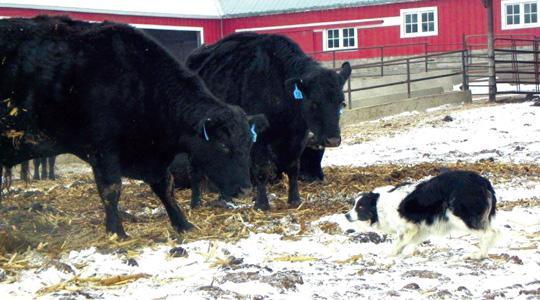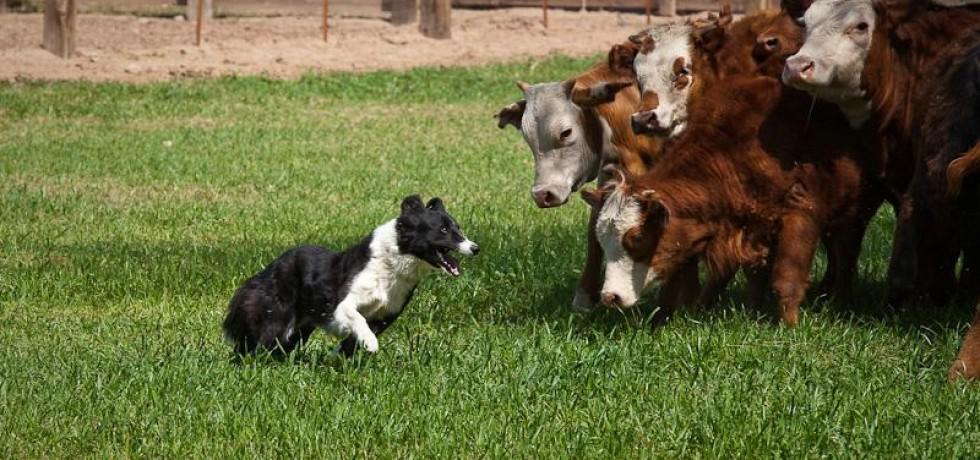The first image is the image on the left, the second image is the image on the right. Given the left and right images, does the statement "Left and right images each show a black-and-white dog in front of multiple standing cattle." hold true? Answer yes or no. Yes. The first image is the image on the left, the second image is the image on the right. Considering the images on both sides, is "One image contains a sheep dog herding three or more sheep." valid? Answer yes or no. No. 